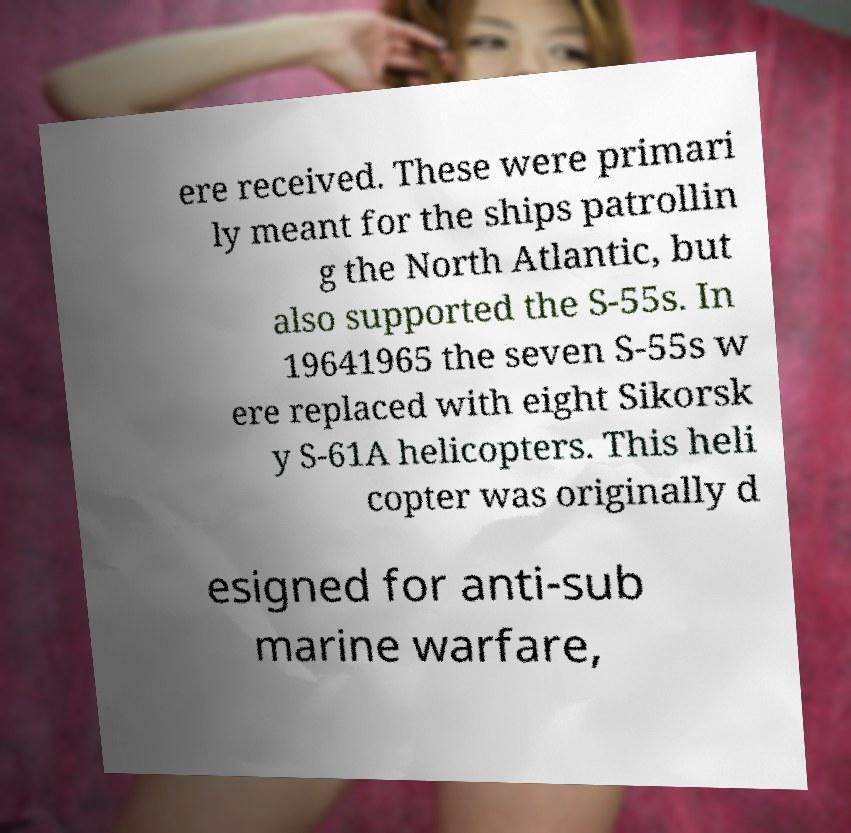Could you assist in decoding the text presented in this image and type it out clearly? ere received. These were primari ly meant for the ships patrollin g the North Atlantic, but also supported the S-55s. In 19641965 the seven S-55s w ere replaced with eight Sikorsk y S-61A helicopters. This heli copter was originally d esigned for anti-sub marine warfare, 